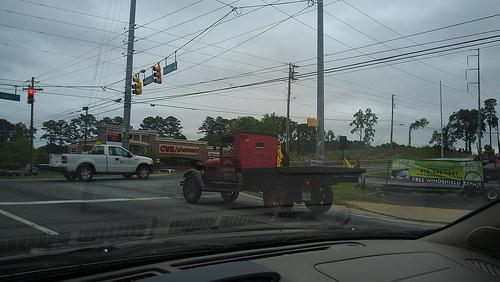Quantify the number of tires on trucks visible in the image. There are six tires on trucks visible in the image. Mention the state of the truck bed. The truck bed is empty. How can the sky be described in the image? The sky in the image is cloudy. Explain the state of the windshield wiper blades. The windshield wiper blades are at rest. Evaluate the overall quality and composition of the image. The overall quality of the image is good, with clear visibility to distinct objects and a balanced composition depicting a busy intersection. Analyze the sentiment and atmosphere of the image. The image depicts a regular day, with the cloudy sky creating a slightly moody atmosphere in the busyness of the intersection. Identify any other vehicles present in the intersection. There is a white pickup truck in the intersection. What is the dominant color of the truck in the image? The dominant color of the truck is red. Determine any possible interactions among objects present in the scene. Objects in the scene such as trucks, traffic lights, street signs, and the pharmacy interact with each other indicating a busy intersection where people, vehicles, and infrastructure coexist. Identify the type of the red truck in the image. antique flat bed truck Which vehicle is present at the intersection? B. White truck How many tires can be seen on the trucks in the image? 6 What type of decorations are found on the edges of the road? banners Does the truck have a loaded back instead of being empty? The instruction contains wrong information about the truck, as its back is actually empty, not loaded. Identify the activity occurring with the two trucks in the image. parked on the road List the notable features of the pole in the image. long and straight Describe the position of the light at the intersection. hanging over the road What color are the traffic lights in the image? yellow State the condition of the sky in the picture. cloudy State the condition of the truck bed for the red truck in the image. empty What color is the truck at the left side of the image? white Are the traffic lights on the ground instead of hanging over the road? The instruction contains wrong information about the position of the traffic lights. They are hanging over the road, not on the ground. What is the color of the street signs? green Are the street lights green instead of yellow? The instruction contradicts the color of the street lights, which are yellow, not green. Locate an item in the car that is for safety purposes. airbag What is the color of the lettering on the truck? red Determine the quality of the road. tarmacked What is at rest on the car in the image? windshield wiper blades Name the type of place found at the intersection. pharmacy Is the building blue in color? The instruction contains the wrong attribute of the color about the building. The actual building color is tan, not blue. Which objects are on display at the intersection? traffic lights and street signs What type of utility lines are found on metal poles in the image? multiple Describe the type and location of the lines on the road. white lines on the road Is the sky sunny and clear? This instruction contradicts the actual attribute of the sky, which is cloudy, not sunny and clear. Is the pole bent on the side? The instruction contradicts the attribute of the pole. The pole is straight, not bent. 